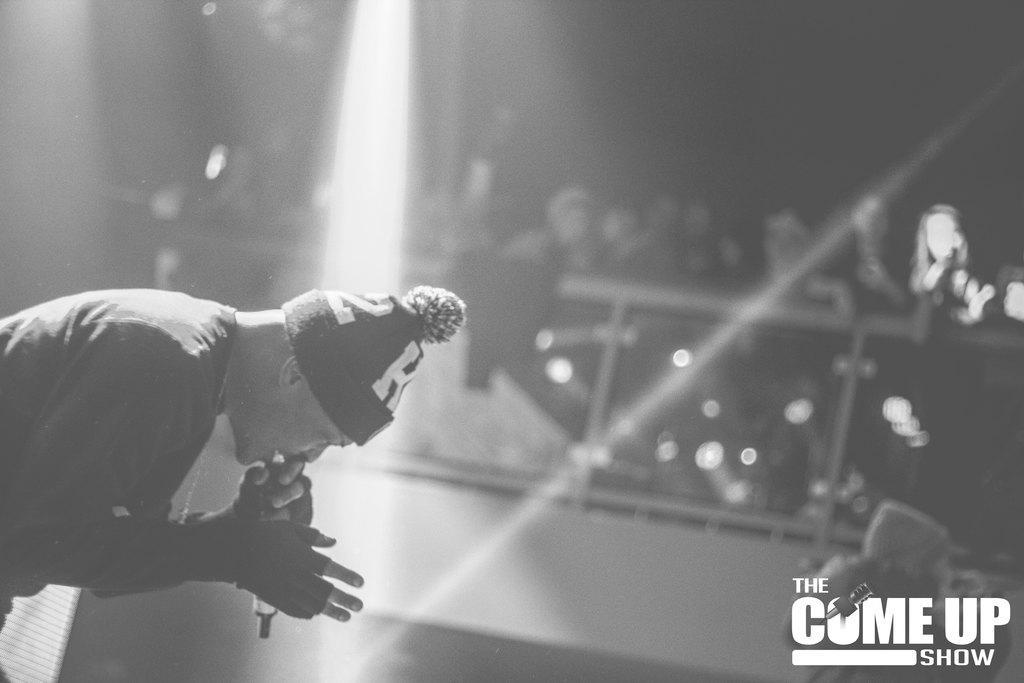Could you give a brief overview of what you see in this image? In the left side a man is singing, he wore a cap here many people are standing and observing him. 